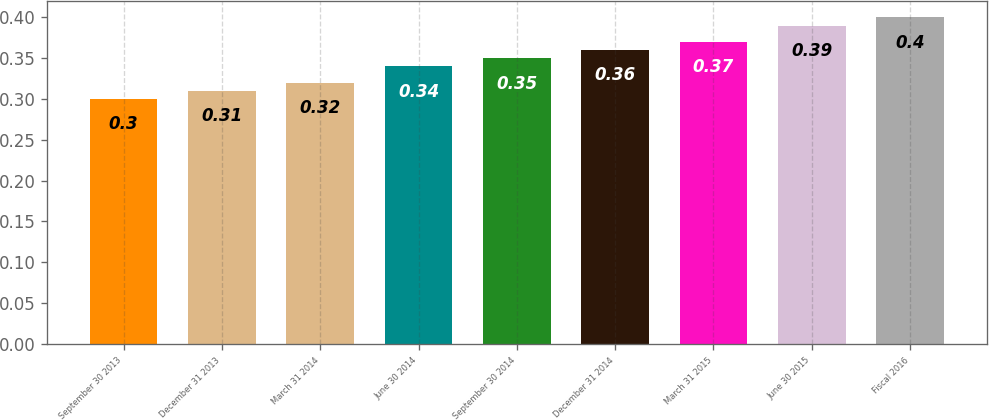Convert chart to OTSL. <chart><loc_0><loc_0><loc_500><loc_500><bar_chart><fcel>September 30 2013<fcel>December 31 2013<fcel>March 31 2014<fcel>June 30 2014<fcel>September 30 2014<fcel>December 31 2014<fcel>March 31 2015<fcel>June 30 2015<fcel>Fiscal 2016<nl><fcel>0.3<fcel>0.31<fcel>0.32<fcel>0.34<fcel>0.35<fcel>0.36<fcel>0.37<fcel>0.39<fcel>0.4<nl></chart> 